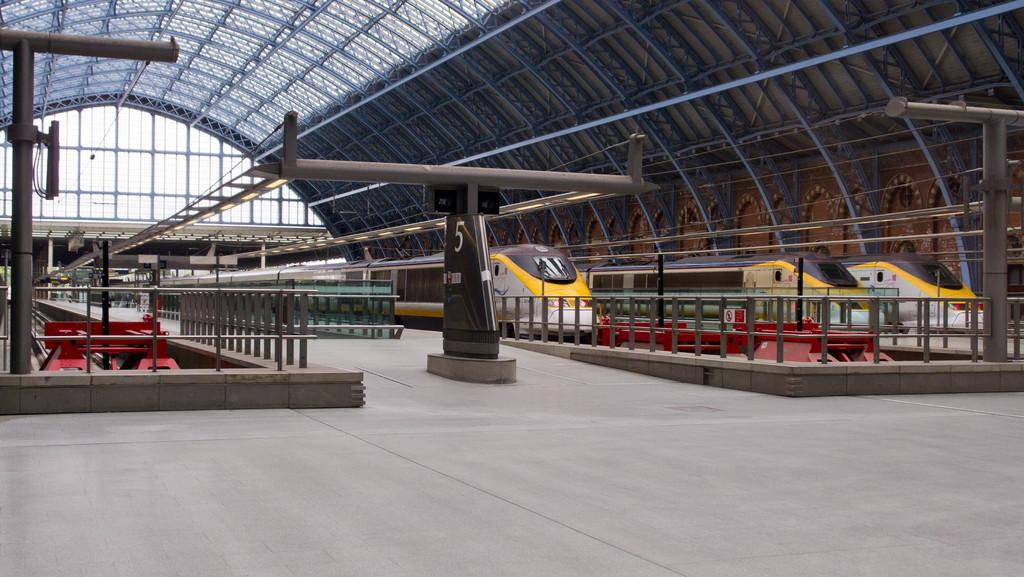What type of vehicles can be seen in the image? There are trains in the image. What type of structure is present in the image? There is an iron grill in the image. What can be seen under the trains and iron grill? The floor is visible in the image. What are the poles used for in the image? The poles are likely used for supporting structures or wires in the image. What type of lights are present in the image? Signal lights are present in the image. What part of the natural environment is visible in the image? The sky is visible in the image. What type of building is present in the image? There is a shed in the image. What type of skirt is hanging on the pole in the image? There is no skirt present in the image; the poles are likely used for supporting structures or wires. Can you describe how the coal is being transported by the trains in the image? There is no coal mentioned in the image, and the trains are not shown transporting any cargo. 